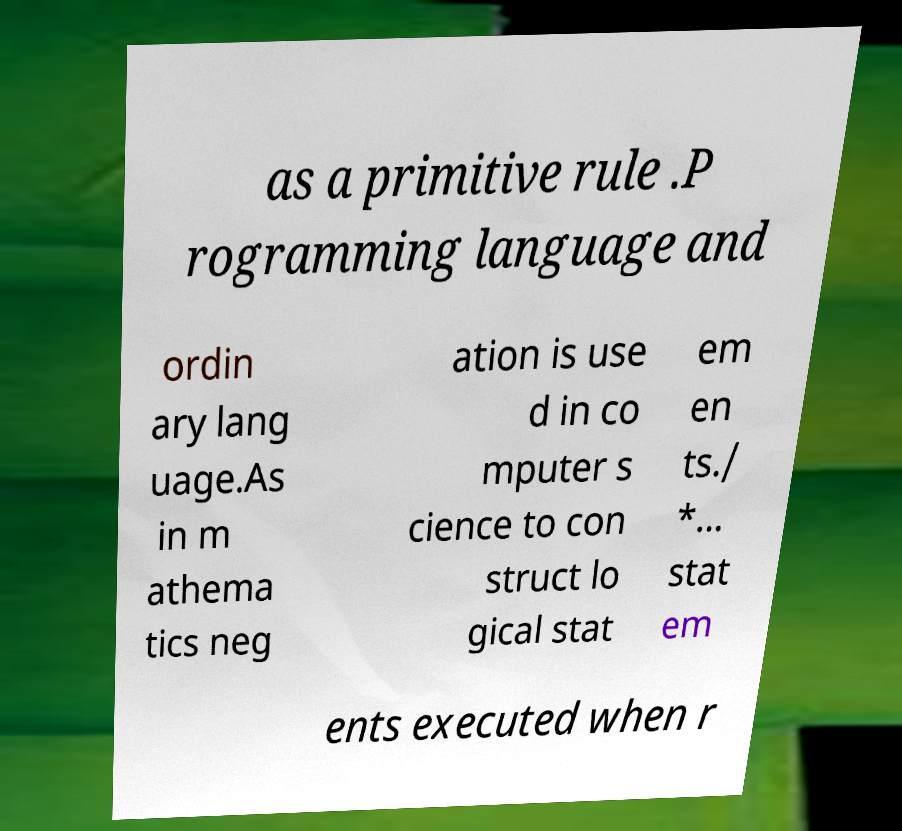Could you assist in decoding the text presented in this image and type it out clearly? as a primitive rule .P rogramming language and ordin ary lang uage.As in m athema tics neg ation is use d in co mputer s cience to con struct lo gical stat em en ts./ *... stat em ents executed when r 